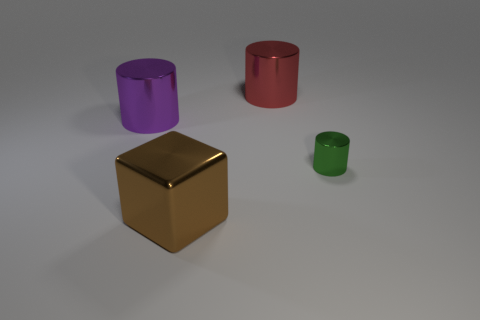Is there anything else that has the same size as the green thing?
Make the answer very short. No. What is the shape of the thing that is both on the right side of the purple thing and left of the red metal cylinder?
Offer a very short reply. Cube. What color is the cube that is made of the same material as the tiny cylinder?
Keep it short and to the point. Brown. Are there the same number of shiny cylinders on the right side of the large red cylinder and purple shiny balls?
Your answer should be very brief. No. The red thing that is the same size as the brown metallic object is what shape?
Your response must be concise. Cylinder. What number of other objects are the same shape as the brown object?
Your answer should be compact. 0. There is a brown metal thing; does it have the same size as the cylinder that is on the left side of the brown block?
Offer a very short reply. Yes. How many things are either large things that are in front of the green cylinder or large gray matte cylinders?
Your response must be concise. 1. There is a metallic thing in front of the green metal thing; what is its shape?
Ensure brevity in your answer.  Cube. Are there an equal number of green cylinders that are behind the big red metal thing and tiny green metallic cylinders on the left side of the tiny green shiny cylinder?
Your response must be concise. Yes. 